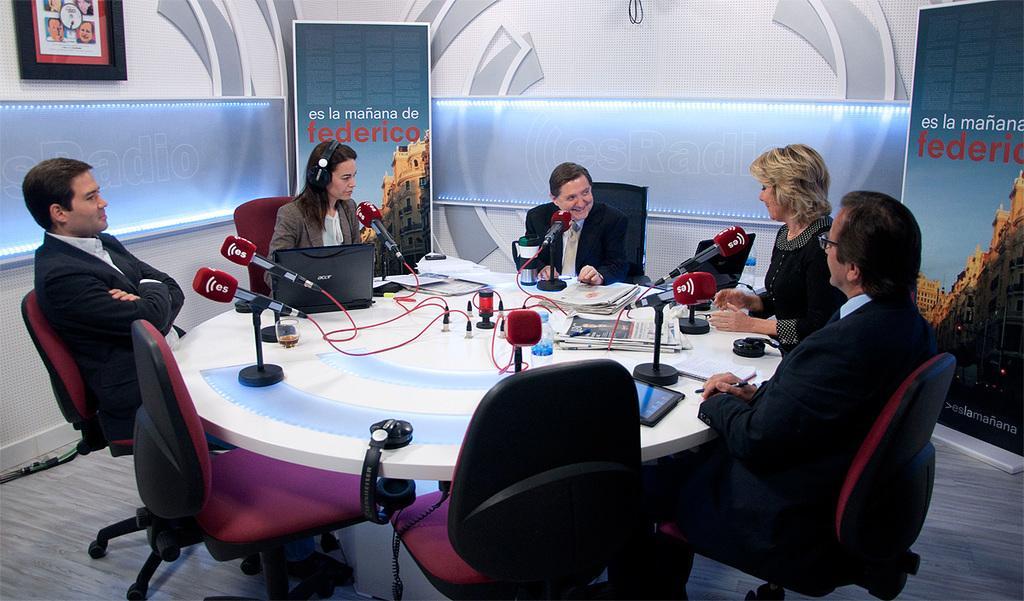In one or two sentences, can you explain what this image depicts? people are seated on the chairs around the table. on the table there are microphones, papers. behind them there are 2 banners on the left and right on which Federico is written. 